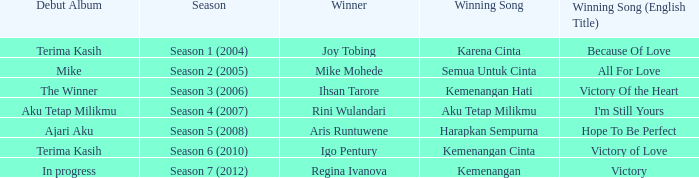Which winning song had a debut album in progress? Kemenangan. 